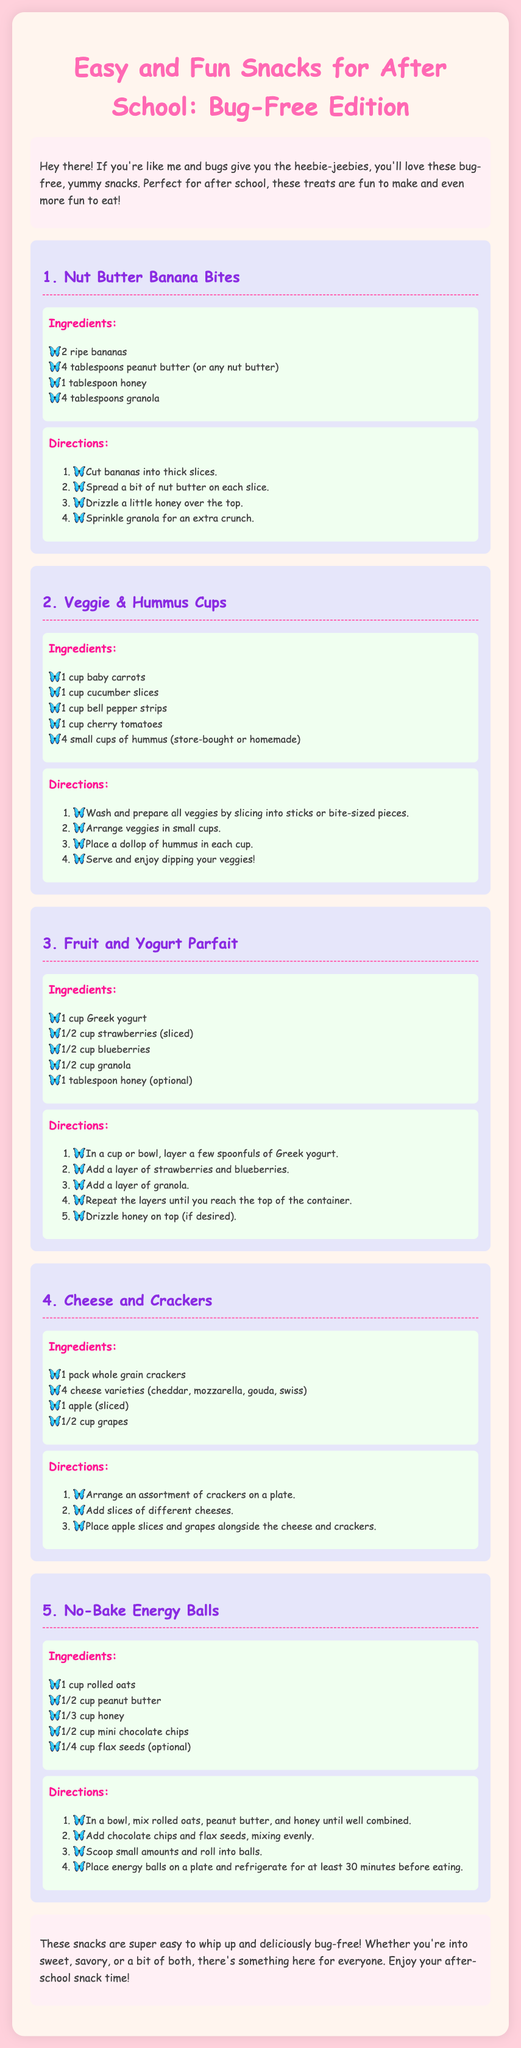What is the title of the document? The title of the document is displayed prominently at the top of the rendered page.
Answer: Easy and Fun Snacks for After School: Bug-Free Edition How many ingredients are needed for Veggie & Hummus Cups? The list of ingredients for Veggie & Hummus Cups is provided, showing a total of 5 items.
Answer: 5 What is the first step in making Nut Butter Banana Bites? The directions for Nut Butter Banana Bites start by indicating the first action to take.
Answer: Cut bananas into thick slices Which fruit is included in the Cheese and Crackers snack? The ingredients section mentions various fruits for the Cheese and Crackers snack.
Answer: Apple How long should No-Bake Energy Balls be refrigerated? The directions provide a specific time mentioned for refrigeration before eating the energy balls.
Answer: 30 minutes 